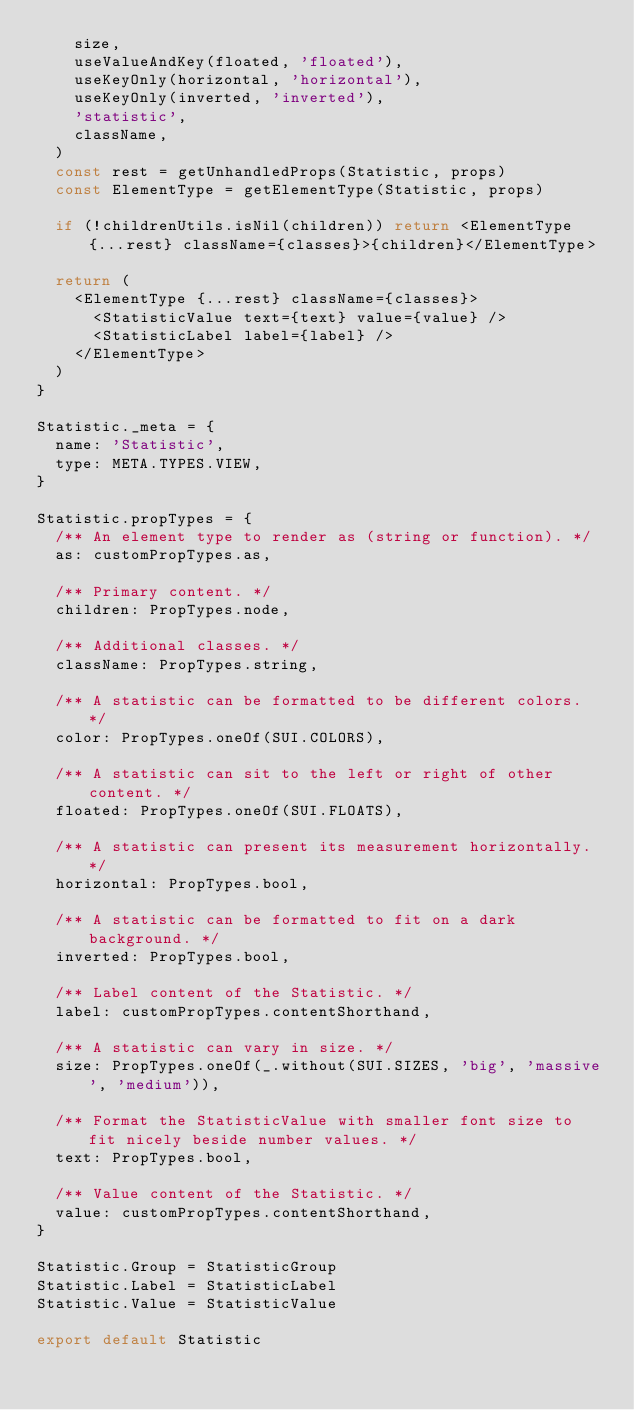<code> <loc_0><loc_0><loc_500><loc_500><_JavaScript_>    size,
    useValueAndKey(floated, 'floated'),
    useKeyOnly(horizontal, 'horizontal'),
    useKeyOnly(inverted, 'inverted'),
    'statistic',
    className,
  )
  const rest = getUnhandledProps(Statistic, props)
  const ElementType = getElementType(Statistic, props)

  if (!childrenUtils.isNil(children)) return <ElementType {...rest} className={classes}>{children}</ElementType>

  return (
    <ElementType {...rest} className={classes}>
      <StatisticValue text={text} value={value} />
      <StatisticLabel label={label} />
    </ElementType>
  )
}

Statistic._meta = {
  name: 'Statistic',
  type: META.TYPES.VIEW,
}

Statistic.propTypes = {
  /** An element type to render as (string or function). */
  as: customPropTypes.as,

  /** Primary content. */
  children: PropTypes.node,

  /** Additional classes. */
  className: PropTypes.string,

  /** A statistic can be formatted to be different colors. */
  color: PropTypes.oneOf(SUI.COLORS),

  /** A statistic can sit to the left or right of other content. */
  floated: PropTypes.oneOf(SUI.FLOATS),

  /** A statistic can present its measurement horizontally. */
  horizontal: PropTypes.bool,

  /** A statistic can be formatted to fit on a dark background. */
  inverted: PropTypes.bool,

  /** Label content of the Statistic. */
  label: customPropTypes.contentShorthand,

  /** A statistic can vary in size. */
  size: PropTypes.oneOf(_.without(SUI.SIZES, 'big', 'massive', 'medium')),

  /** Format the StatisticValue with smaller font size to fit nicely beside number values. */
  text: PropTypes.bool,

  /** Value content of the Statistic. */
  value: customPropTypes.contentShorthand,
}

Statistic.Group = StatisticGroup
Statistic.Label = StatisticLabel
Statistic.Value = StatisticValue

export default Statistic
</code> 